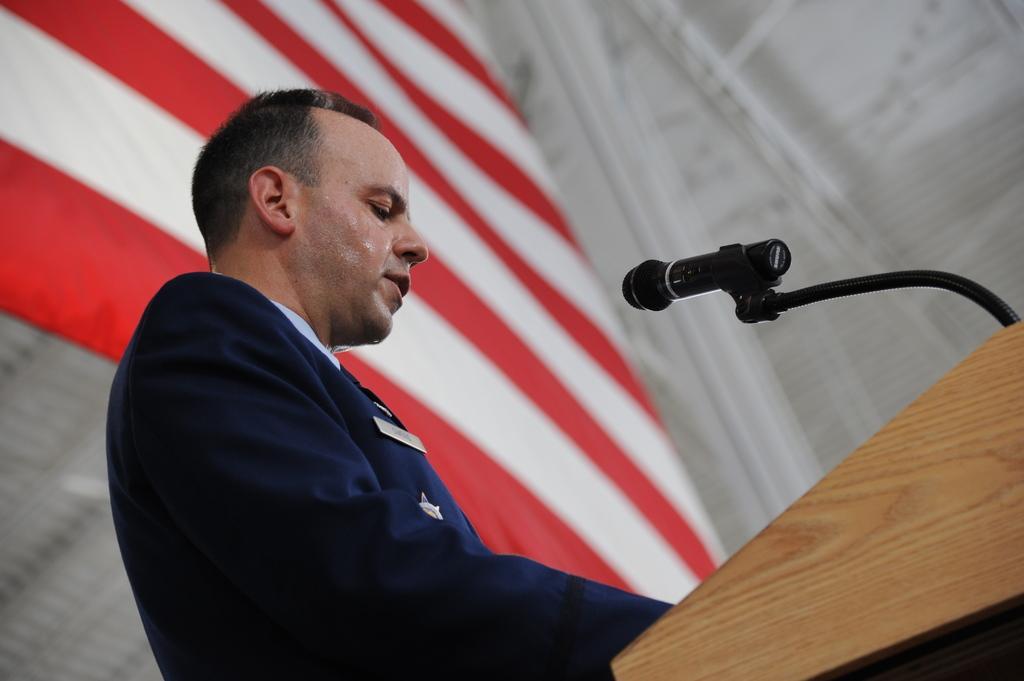In one or two sentences, can you explain what this image depicts? There is a man standing,in front of this man we can see microphone on the podium,behind this man we can see white and red color banner. In the background it is white color. 